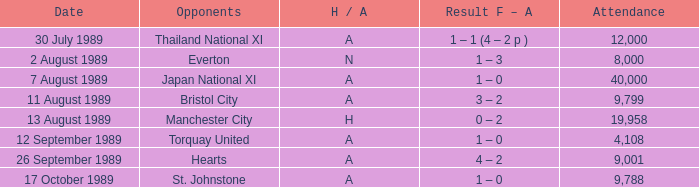What was the attendance for the game between manchester united and hearts? 9001.0. 